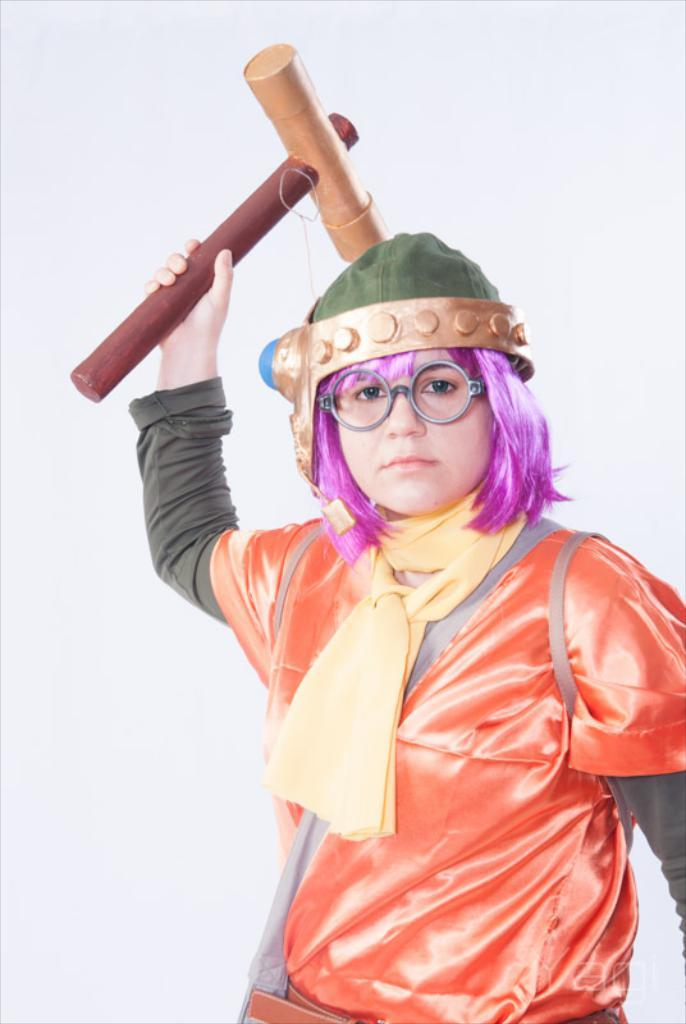Who is present in the image? There is a woman in the image. What is the woman holding in the image? The woman is holding a hammer. What color is the background of the image? The background of the image is white. What type of snake can be seen slithering in the background of the image? There is no snake present in the image; the background is white. 